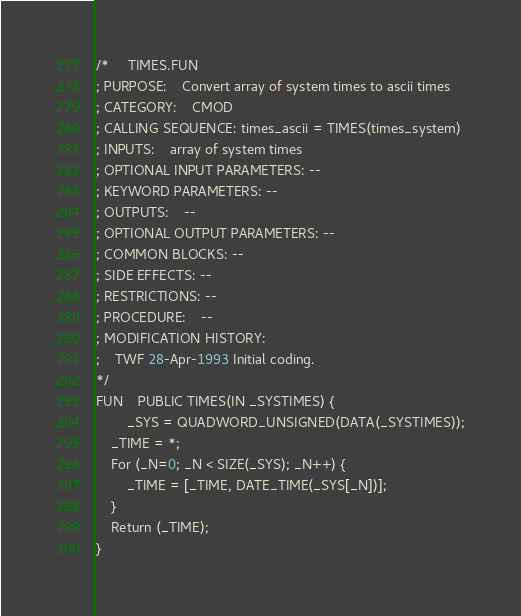<code> <loc_0><loc_0><loc_500><loc_500><_SML_>/*	 TIMES.FUN
; PURPOSE:	Convert array of system times to ascii times
; CATEGORY:	CMOD
; CALLING SEQUENCE: times_ascii = TIMES(times_system)
; INPUTS:	array of system times
; OPTIONAL INPUT PARAMETERS: --
; KEYWORD PARAMETERS: --
; OUTPUTS:	--
; OPTIONAL OUTPUT PARAMETERS: --
; COMMON BLOCKS: --
; SIDE EFFECTS: --
; RESTRICTIONS: --
; PROCEDURE:	--
; MODIFICATION HISTORY:
;	TWF 28-Apr-1993 Initial coding.
*/
FUN	PUBLIC TIMES(IN _SYSTIMES) {
        _SYS = QUADWORD_UNSIGNED(DATA(_SYSTIMES));
	_TIME = *;
	For (_N=0; _N < SIZE(_SYS); _N++) {
		_TIME = [_TIME, DATE_TIME(_SYS[_N])];
	}
	Return (_TIME);
}

</code> 